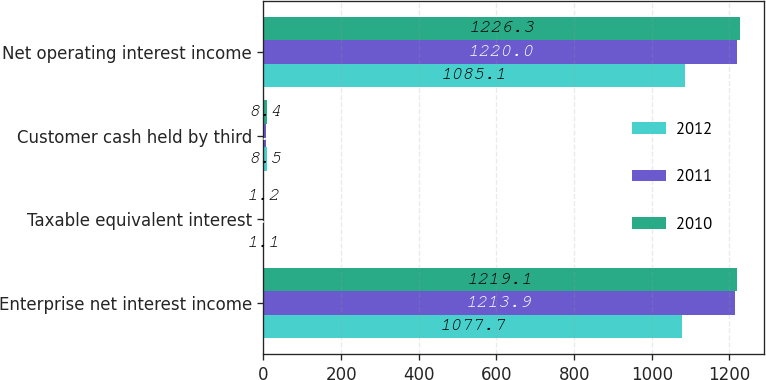Convert chart to OTSL. <chart><loc_0><loc_0><loc_500><loc_500><stacked_bar_chart><ecel><fcel>Enterprise net interest income<fcel>Taxable equivalent interest<fcel>Customer cash held by third<fcel>Net operating interest income<nl><fcel>2012<fcel>1077.7<fcel>1.1<fcel>8.5<fcel>1085.1<nl><fcel>2011<fcel>1213.9<fcel>1.2<fcel>7.3<fcel>1220<nl><fcel>2010<fcel>1219.1<fcel>1.2<fcel>8.4<fcel>1226.3<nl></chart> 